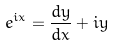Convert formula to latex. <formula><loc_0><loc_0><loc_500><loc_500>e ^ { i x } = \frac { d y } { d x } + i y</formula> 